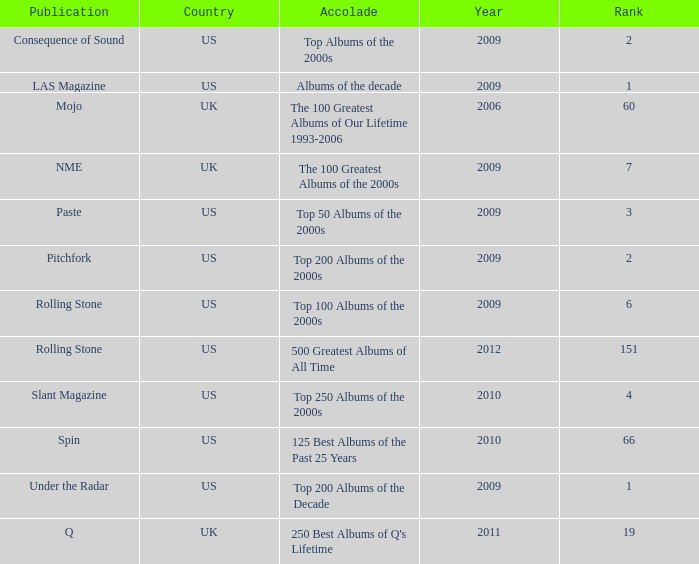What was the lowest rank after 2009 with an accolade of 125 best albums of the past 25 years? 66.0. 